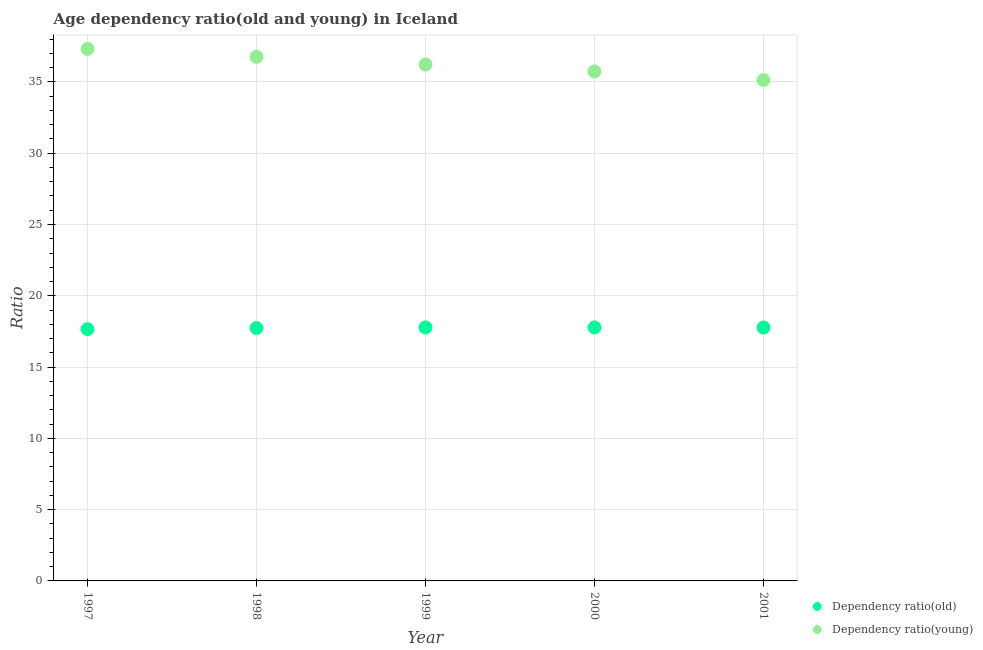Is the number of dotlines equal to the number of legend labels?
Your answer should be compact. Yes. What is the age dependency ratio(old) in 2000?
Your answer should be compact. 17.78. Across all years, what is the maximum age dependency ratio(young)?
Make the answer very short. 37.32. Across all years, what is the minimum age dependency ratio(young)?
Your answer should be compact. 35.13. In which year was the age dependency ratio(young) maximum?
Give a very brief answer. 1997. In which year was the age dependency ratio(young) minimum?
Provide a short and direct response. 2001. What is the total age dependency ratio(young) in the graph?
Your response must be concise. 181.16. What is the difference between the age dependency ratio(young) in 1998 and that in 2001?
Ensure brevity in your answer.  1.63. What is the difference between the age dependency ratio(old) in 1999 and the age dependency ratio(young) in 1998?
Ensure brevity in your answer.  -18.98. What is the average age dependency ratio(young) per year?
Provide a succinct answer. 36.23. In the year 2000, what is the difference between the age dependency ratio(young) and age dependency ratio(old)?
Provide a short and direct response. 17.95. What is the ratio of the age dependency ratio(young) in 2000 to that in 2001?
Ensure brevity in your answer.  1.02. Is the age dependency ratio(old) in 1997 less than that in 2000?
Ensure brevity in your answer.  Yes. Is the difference between the age dependency ratio(young) in 1998 and 1999 greater than the difference between the age dependency ratio(old) in 1998 and 1999?
Your answer should be very brief. Yes. What is the difference between the highest and the second highest age dependency ratio(young)?
Your answer should be very brief. 0.56. What is the difference between the highest and the lowest age dependency ratio(old)?
Your response must be concise. 0.12. Are the values on the major ticks of Y-axis written in scientific E-notation?
Your response must be concise. No. Does the graph contain any zero values?
Give a very brief answer. No. How are the legend labels stacked?
Offer a terse response. Vertical. What is the title of the graph?
Provide a succinct answer. Age dependency ratio(old and young) in Iceland. Does "RDB concessional" appear as one of the legend labels in the graph?
Keep it short and to the point. No. What is the label or title of the Y-axis?
Make the answer very short. Ratio. What is the Ratio in Dependency ratio(old) in 1997?
Make the answer very short. 17.66. What is the Ratio of Dependency ratio(young) in 1997?
Provide a succinct answer. 37.32. What is the Ratio of Dependency ratio(old) in 1998?
Your answer should be very brief. 17.74. What is the Ratio in Dependency ratio(young) in 1998?
Offer a very short reply. 36.76. What is the Ratio in Dependency ratio(old) in 1999?
Make the answer very short. 17.78. What is the Ratio of Dependency ratio(young) in 1999?
Ensure brevity in your answer.  36.21. What is the Ratio of Dependency ratio(old) in 2000?
Your response must be concise. 17.78. What is the Ratio of Dependency ratio(young) in 2000?
Make the answer very short. 35.73. What is the Ratio of Dependency ratio(old) in 2001?
Your response must be concise. 17.78. What is the Ratio of Dependency ratio(young) in 2001?
Keep it short and to the point. 35.13. Across all years, what is the maximum Ratio in Dependency ratio(old)?
Offer a very short reply. 17.78. Across all years, what is the maximum Ratio of Dependency ratio(young)?
Offer a very short reply. 37.32. Across all years, what is the minimum Ratio of Dependency ratio(old)?
Make the answer very short. 17.66. Across all years, what is the minimum Ratio in Dependency ratio(young)?
Keep it short and to the point. 35.13. What is the total Ratio in Dependency ratio(old) in the graph?
Your answer should be very brief. 88.75. What is the total Ratio of Dependency ratio(young) in the graph?
Make the answer very short. 181.16. What is the difference between the Ratio in Dependency ratio(old) in 1997 and that in 1998?
Offer a very short reply. -0.08. What is the difference between the Ratio of Dependency ratio(young) in 1997 and that in 1998?
Your answer should be compact. 0.56. What is the difference between the Ratio in Dependency ratio(old) in 1997 and that in 1999?
Provide a succinct answer. -0.12. What is the difference between the Ratio of Dependency ratio(young) in 1997 and that in 1999?
Your answer should be compact. 1.1. What is the difference between the Ratio in Dependency ratio(old) in 1997 and that in 2000?
Offer a very short reply. -0.12. What is the difference between the Ratio in Dependency ratio(young) in 1997 and that in 2000?
Offer a very short reply. 1.58. What is the difference between the Ratio of Dependency ratio(old) in 1997 and that in 2001?
Provide a short and direct response. -0.11. What is the difference between the Ratio in Dependency ratio(young) in 1997 and that in 2001?
Your answer should be very brief. 2.19. What is the difference between the Ratio of Dependency ratio(old) in 1998 and that in 1999?
Ensure brevity in your answer.  -0.05. What is the difference between the Ratio in Dependency ratio(young) in 1998 and that in 1999?
Make the answer very short. 0.55. What is the difference between the Ratio in Dependency ratio(old) in 1998 and that in 2000?
Your answer should be very brief. -0.05. What is the difference between the Ratio in Dependency ratio(young) in 1998 and that in 2000?
Your response must be concise. 1.03. What is the difference between the Ratio in Dependency ratio(old) in 1998 and that in 2001?
Offer a very short reply. -0.04. What is the difference between the Ratio of Dependency ratio(young) in 1998 and that in 2001?
Your response must be concise. 1.63. What is the difference between the Ratio of Dependency ratio(old) in 1999 and that in 2000?
Make the answer very short. -0. What is the difference between the Ratio in Dependency ratio(young) in 1999 and that in 2000?
Your response must be concise. 0.48. What is the difference between the Ratio of Dependency ratio(old) in 1999 and that in 2001?
Your response must be concise. 0.01. What is the difference between the Ratio in Dependency ratio(young) in 1999 and that in 2001?
Make the answer very short. 1.08. What is the difference between the Ratio of Dependency ratio(old) in 2000 and that in 2001?
Keep it short and to the point. 0.01. What is the difference between the Ratio of Dependency ratio(young) in 2000 and that in 2001?
Provide a succinct answer. 0.6. What is the difference between the Ratio of Dependency ratio(old) in 1997 and the Ratio of Dependency ratio(young) in 1998?
Offer a terse response. -19.1. What is the difference between the Ratio in Dependency ratio(old) in 1997 and the Ratio in Dependency ratio(young) in 1999?
Keep it short and to the point. -18.55. What is the difference between the Ratio of Dependency ratio(old) in 1997 and the Ratio of Dependency ratio(young) in 2000?
Keep it short and to the point. -18.07. What is the difference between the Ratio of Dependency ratio(old) in 1997 and the Ratio of Dependency ratio(young) in 2001?
Ensure brevity in your answer.  -17.47. What is the difference between the Ratio in Dependency ratio(old) in 1998 and the Ratio in Dependency ratio(young) in 1999?
Ensure brevity in your answer.  -18.48. What is the difference between the Ratio in Dependency ratio(old) in 1998 and the Ratio in Dependency ratio(young) in 2000?
Provide a short and direct response. -17.99. What is the difference between the Ratio of Dependency ratio(old) in 1998 and the Ratio of Dependency ratio(young) in 2001?
Provide a succinct answer. -17.39. What is the difference between the Ratio in Dependency ratio(old) in 1999 and the Ratio in Dependency ratio(young) in 2000?
Your answer should be very brief. -17.95. What is the difference between the Ratio of Dependency ratio(old) in 1999 and the Ratio of Dependency ratio(young) in 2001?
Ensure brevity in your answer.  -17.35. What is the difference between the Ratio in Dependency ratio(old) in 2000 and the Ratio in Dependency ratio(young) in 2001?
Make the answer very short. -17.35. What is the average Ratio of Dependency ratio(old) per year?
Make the answer very short. 17.75. What is the average Ratio of Dependency ratio(young) per year?
Provide a succinct answer. 36.23. In the year 1997, what is the difference between the Ratio of Dependency ratio(old) and Ratio of Dependency ratio(young)?
Keep it short and to the point. -19.65. In the year 1998, what is the difference between the Ratio of Dependency ratio(old) and Ratio of Dependency ratio(young)?
Offer a very short reply. -19.02. In the year 1999, what is the difference between the Ratio in Dependency ratio(old) and Ratio in Dependency ratio(young)?
Offer a very short reply. -18.43. In the year 2000, what is the difference between the Ratio in Dependency ratio(old) and Ratio in Dependency ratio(young)?
Offer a terse response. -17.95. In the year 2001, what is the difference between the Ratio of Dependency ratio(old) and Ratio of Dependency ratio(young)?
Your answer should be compact. -17.35. What is the ratio of the Ratio in Dependency ratio(old) in 1997 to that in 1998?
Your answer should be compact. 1. What is the ratio of the Ratio in Dependency ratio(young) in 1997 to that in 1998?
Provide a succinct answer. 1.02. What is the ratio of the Ratio in Dependency ratio(old) in 1997 to that in 1999?
Your answer should be very brief. 0.99. What is the ratio of the Ratio of Dependency ratio(young) in 1997 to that in 1999?
Provide a succinct answer. 1.03. What is the ratio of the Ratio in Dependency ratio(young) in 1997 to that in 2000?
Provide a short and direct response. 1.04. What is the ratio of the Ratio of Dependency ratio(old) in 1997 to that in 2001?
Make the answer very short. 0.99. What is the ratio of the Ratio in Dependency ratio(young) in 1997 to that in 2001?
Offer a terse response. 1.06. What is the ratio of the Ratio of Dependency ratio(old) in 1998 to that in 1999?
Your answer should be compact. 1. What is the ratio of the Ratio of Dependency ratio(young) in 1998 to that in 1999?
Offer a very short reply. 1.02. What is the ratio of the Ratio of Dependency ratio(young) in 1998 to that in 2000?
Your answer should be very brief. 1.03. What is the ratio of the Ratio of Dependency ratio(young) in 1998 to that in 2001?
Ensure brevity in your answer.  1.05. What is the ratio of the Ratio in Dependency ratio(old) in 1999 to that in 2000?
Provide a short and direct response. 1. What is the ratio of the Ratio in Dependency ratio(young) in 1999 to that in 2000?
Offer a terse response. 1.01. What is the ratio of the Ratio of Dependency ratio(young) in 1999 to that in 2001?
Offer a very short reply. 1.03. What is the ratio of the Ratio in Dependency ratio(young) in 2000 to that in 2001?
Ensure brevity in your answer.  1.02. What is the difference between the highest and the second highest Ratio of Dependency ratio(old)?
Make the answer very short. 0. What is the difference between the highest and the second highest Ratio in Dependency ratio(young)?
Offer a terse response. 0.56. What is the difference between the highest and the lowest Ratio in Dependency ratio(old)?
Ensure brevity in your answer.  0.12. What is the difference between the highest and the lowest Ratio of Dependency ratio(young)?
Provide a short and direct response. 2.19. 